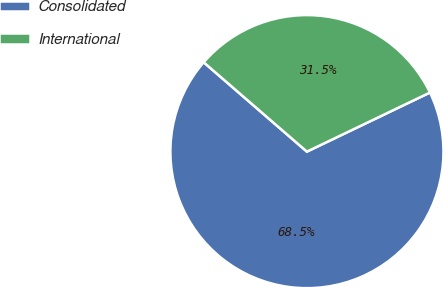<chart> <loc_0><loc_0><loc_500><loc_500><pie_chart><fcel>Consolidated<fcel>International<nl><fcel>68.48%<fcel>31.52%<nl></chart> 